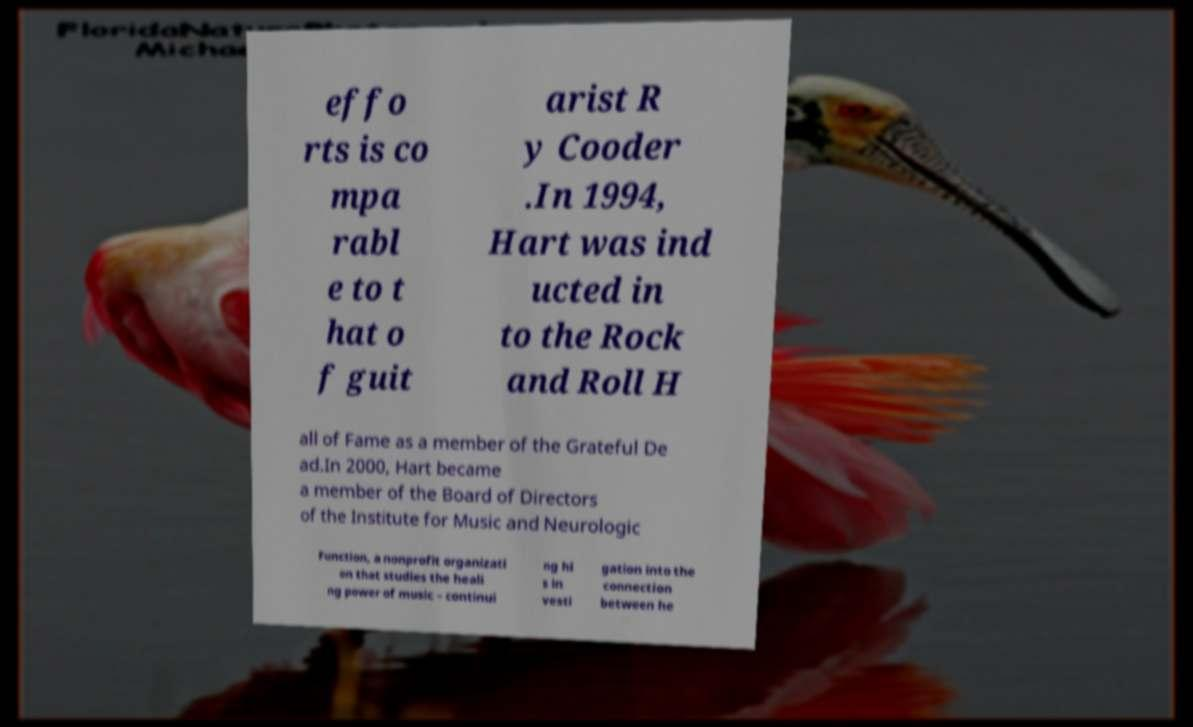What messages or text are displayed in this image? I need them in a readable, typed format. effo rts is co mpa rabl e to t hat o f guit arist R y Cooder .In 1994, Hart was ind ucted in to the Rock and Roll H all of Fame as a member of the Grateful De ad.In 2000, Hart became a member of the Board of Directors of the Institute for Music and Neurologic Function, a nonprofit organizati on that studies the heali ng power of music – continui ng hi s in vesti gation into the connection between he 